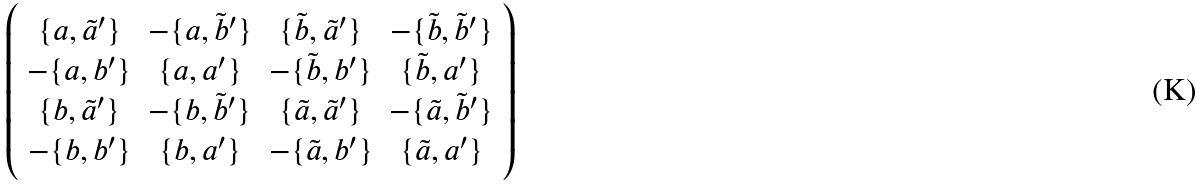Convert formula to latex. <formula><loc_0><loc_0><loc_500><loc_500>\left ( \begin{array} { c c c c } \{ a , \tilde { a } ^ { \prime } \} & - \{ a , \tilde { b } ^ { \prime } \} & \{ \tilde { b } , \tilde { a } ^ { \prime } \} & - \{ \tilde { b } , \tilde { b } ^ { \prime } \} \\ - \{ a , b ^ { \prime } \} & \{ a , a ^ { \prime } \} & - \{ \tilde { b } , b ^ { \prime } \} & \{ \tilde { b } , a ^ { \prime } \} \\ \{ b , \tilde { a } ^ { \prime } \} & - \{ b , \tilde { b } ^ { \prime } \} & \{ \tilde { a } , \tilde { a } ^ { \prime } \} & - \{ \tilde { a } , \tilde { b } ^ { \prime } \} \\ - \{ b , b ^ { \prime } \} & \{ b , a ^ { \prime } \} & - \{ \tilde { a } , b ^ { \prime } \} & \{ \tilde { a } , a ^ { \prime } \} \end{array} \right )</formula> 